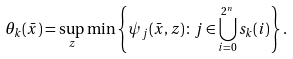<formula> <loc_0><loc_0><loc_500><loc_500>\theta _ { k } ( \bar { x } ) = \sup _ { z } \min \left \{ \psi _ { j } ( \bar { x } , z ) \colon j \in \bigcup _ { i = 0 } ^ { 2 ^ { n } } s _ { k } ( i ) \right \} .</formula> 